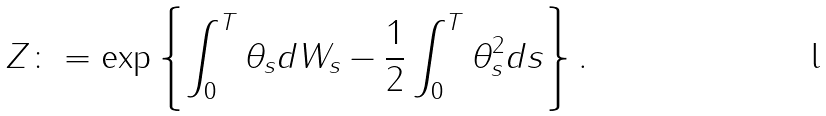<formula> <loc_0><loc_0><loc_500><loc_500>Z & \colon = \exp \left \{ \int _ { 0 } ^ { T } \theta _ { s } d W _ { s } - \frac { 1 } { 2 } \int _ { 0 } ^ { T } \theta _ { s } ^ { 2 } d s \right \} .</formula> 